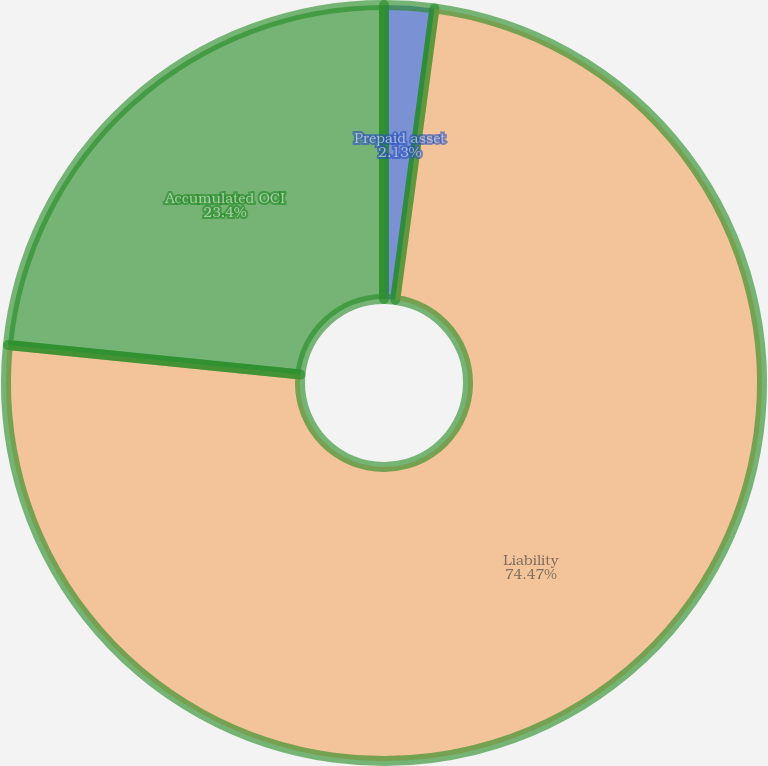Convert chart to OTSL. <chart><loc_0><loc_0><loc_500><loc_500><pie_chart><fcel>Prepaid asset<fcel>Liability<fcel>Accumulated OCI<nl><fcel>2.13%<fcel>74.47%<fcel>23.4%<nl></chart> 